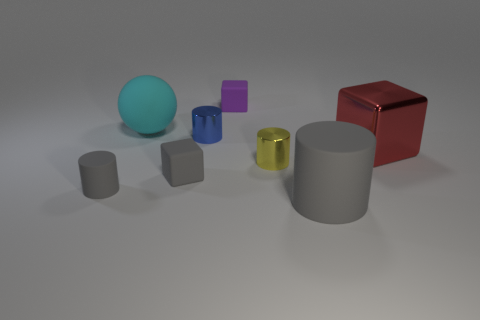Subtract all brown spheres. How many gray cylinders are left? 2 Subtract 1 cubes. How many cubes are left? 2 Subtract all small cylinders. How many cylinders are left? 1 Subtract all yellow cylinders. How many cylinders are left? 3 Add 1 tiny brown shiny blocks. How many objects exist? 9 Subtract all cyan blocks. Subtract all yellow cylinders. How many blocks are left? 3 Add 7 small gray matte objects. How many small gray matte objects exist? 9 Subtract 1 gray cubes. How many objects are left? 7 Subtract all balls. How many objects are left? 7 Subtract all purple rubber things. Subtract all red blocks. How many objects are left? 6 